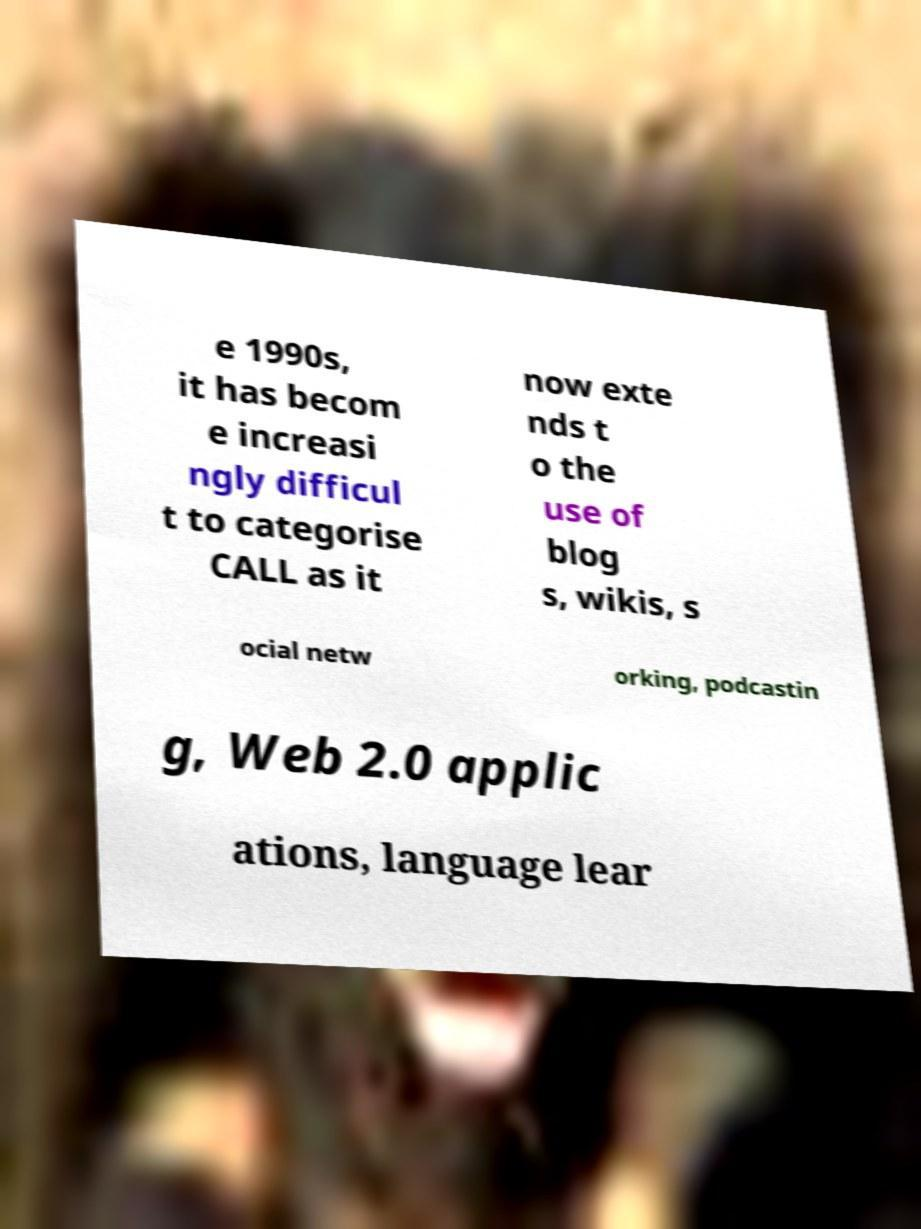Considering the topics mentioned in the text such as Web 2.0 and social networking, what might be the significance of these components in language learning? Web 2.0 and social networking have transformed language learning by facilitating collaborative learning and making resources more accessible. Web 2.0 technologies empower learners to create, share, and interact online, enhancing their engagement and motivation. Social networking can connect learners with native speakers and communities, providing an authentic context for language practice and cultural exchange. 